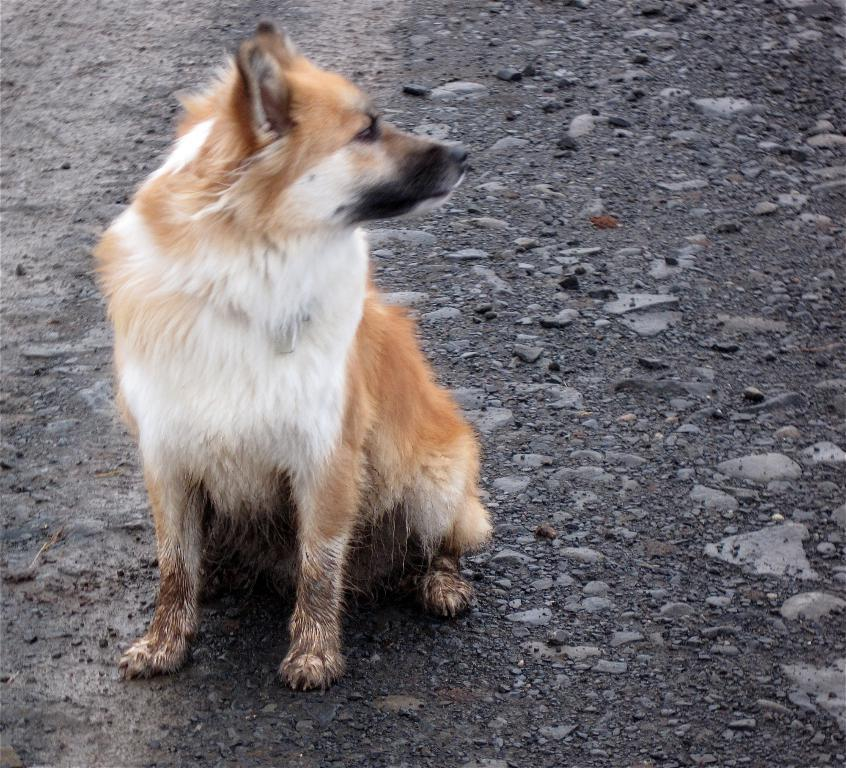What type of animal can be seen in the image? There is a dog in the image. Where is the dog located in the image? The dog is sitting on the road. What is the condition of the road in the image? Mud and small stones are visible on the road. What is the dog rubbing its stomach against in the image? There is no indication in the image that the dog is rubbing its stomach against anything. 